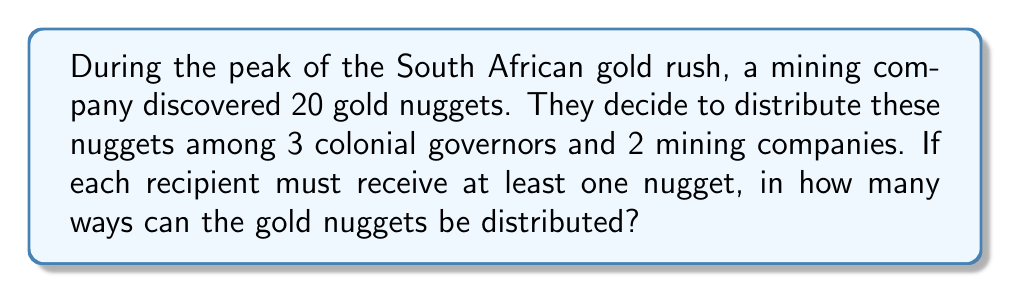What is the answer to this math problem? Let's approach this step-by-step using the concept of stars and bars (or balls and urns) from combinatorics:

1) We have 20 gold nuggets to distribute among 5 recipients (3 governors and 2 companies).

2) Each recipient must get at least one nugget, so we first give one nugget to each recipient. This leaves us with 15 nuggets to distribute freely.

3) Now, we need to find the number of ways to distribute 15 indistinguishable objects (remaining nuggets) into 5 distinguishable containers (recipients).

4) This scenario is a classic application of the stars and bars theorem. The formula for this is:

   $${n+k-1 \choose k-1}$$

   Where $n$ is the number of indistinguishable objects and $k$ is the number of distinguishable containers.

5) In our case, $n = 15$ and $k = 5$. So we need to calculate:

   $${15+5-1 \choose 5-1} = {19 \choose 4}$$

6) We can calculate this using the combination formula:

   $${19 \choose 4} = \frac{19!}{4!(19-4)!} = \frac{19!}{4!15!}$$

7) Calculating this:
   
   $$\frac{19 * 18 * 17 * 16}{4 * 3 * 2 * 1} = 3876$$

Therefore, there are 3876 ways to distribute the gold nuggets.
Answer: 3876 